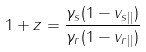Convert formula to latex. <formula><loc_0><loc_0><loc_500><loc_500>1 + z = \frac { \gamma _ { s } ( 1 - v _ { s | | } ) } { \gamma _ { r } ( 1 - v _ { r | | } ) }</formula> 